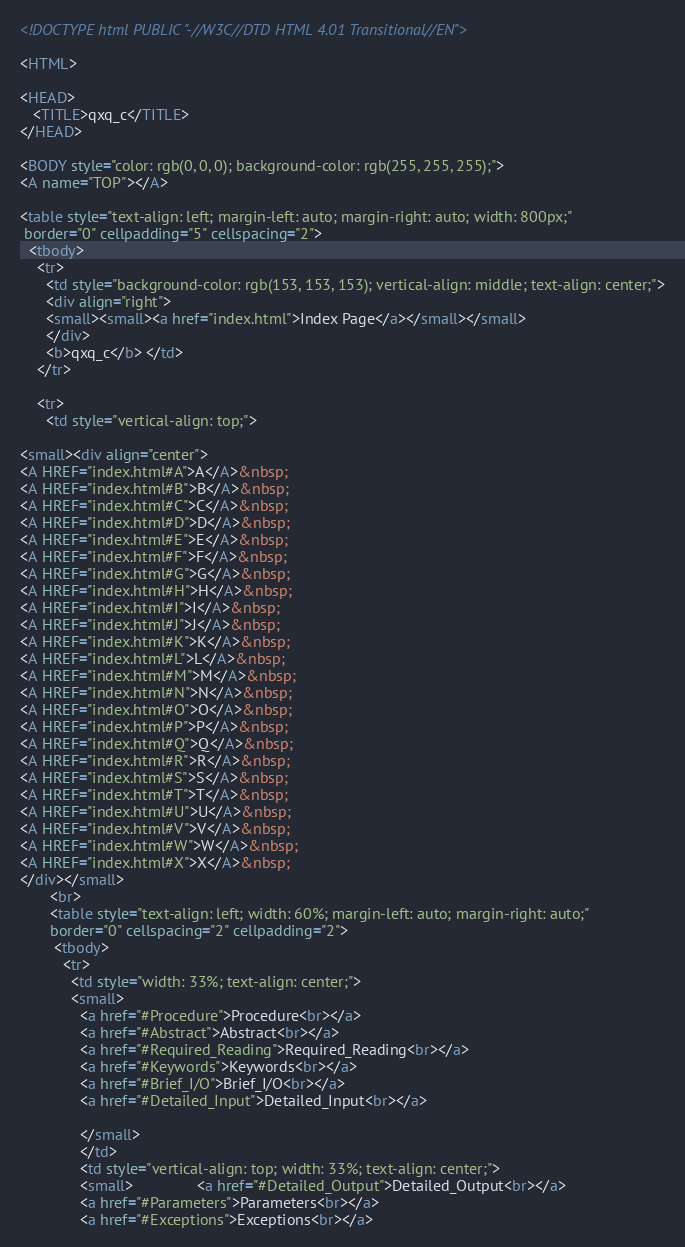<code> <loc_0><loc_0><loc_500><loc_500><_HTML_>
<!DOCTYPE html PUBLIC "-//W3C//DTD HTML 4.01 Transitional//EN">

<HTML>

<HEAD>
   <TITLE>qxq_c</TITLE>
</HEAD>

<BODY style="color: rgb(0, 0, 0); background-color: rgb(255, 255, 255);">
<A name="TOP"></A>

<table style="text-align: left; margin-left: auto; margin-right: auto; width: 800px;"
 border="0" cellpadding="5" cellspacing="2">
  <tbody>
    <tr>
      <td style="background-color: rgb(153, 153, 153); vertical-align: middle; text-align: center;">
      <div align="right"> 
      <small><small><a href="index.html">Index Page</a></small></small>
      </div>
      <b>qxq_c</b> </td>
    </tr>

    <tr>
      <td style="vertical-align: top;">

<small><div align="center">
<A HREF="index.html#A">A</A>&nbsp;
<A HREF="index.html#B">B</A>&nbsp;
<A HREF="index.html#C">C</A>&nbsp;
<A HREF="index.html#D">D</A>&nbsp;
<A HREF="index.html#E">E</A>&nbsp;
<A HREF="index.html#F">F</A>&nbsp;
<A HREF="index.html#G">G</A>&nbsp;
<A HREF="index.html#H">H</A>&nbsp;
<A HREF="index.html#I">I</A>&nbsp;
<A HREF="index.html#J">J</A>&nbsp;
<A HREF="index.html#K">K</A>&nbsp;
<A HREF="index.html#L">L</A>&nbsp;
<A HREF="index.html#M">M</A>&nbsp;
<A HREF="index.html#N">N</A>&nbsp;
<A HREF="index.html#O">O</A>&nbsp;
<A HREF="index.html#P">P</A>&nbsp;
<A HREF="index.html#Q">Q</A>&nbsp;
<A HREF="index.html#R">R</A>&nbsp;
<A HREF="index.html#S">S</A>&nbsp;
<A HREF="index.html#T">T</A>&nbsp;
<A HREF="index.html#U">U</A>&nbsp;
<A HREF="index.html#V">V</A>&nbsp;
<A HREF="index.html#W">W</A>&nbsp;
<A HREF="index.html#X">X</A>&nbsp;
</div></small>
       <br>
       <table style="text-align: left; width: 60%; margin-left: auto; margin-right: auto;"
       border="0" cellspacing="2" cellpadding="2">
        <tbody>
          <tr>
            <td style="width: 33%; text-align: center;">
            <small>
              <a href="#Procedure">Procedure<br></a>
              <a href="#Abstract">Abstract<br></a>
              <a href="#Required_Reading">Required_Reading<br></a>
              <a href="#Keywords">Keywords<br></a>
              <a href="#Brief_I/O">Brief_I/O<br></a>
              <a href="#Detailed_Input">Detailed_Input<br></a>

              </small>
              </td>
              <td style="vertical-align: top; width: 33%; text-align: center;">
              <small>               <a href="#Detailed_Output">Detailed_Output<br></a>
              <a href="#Parameters">Parameters<br></a>
              <a href="#Exceptions">Exceptions<br></a></code> 